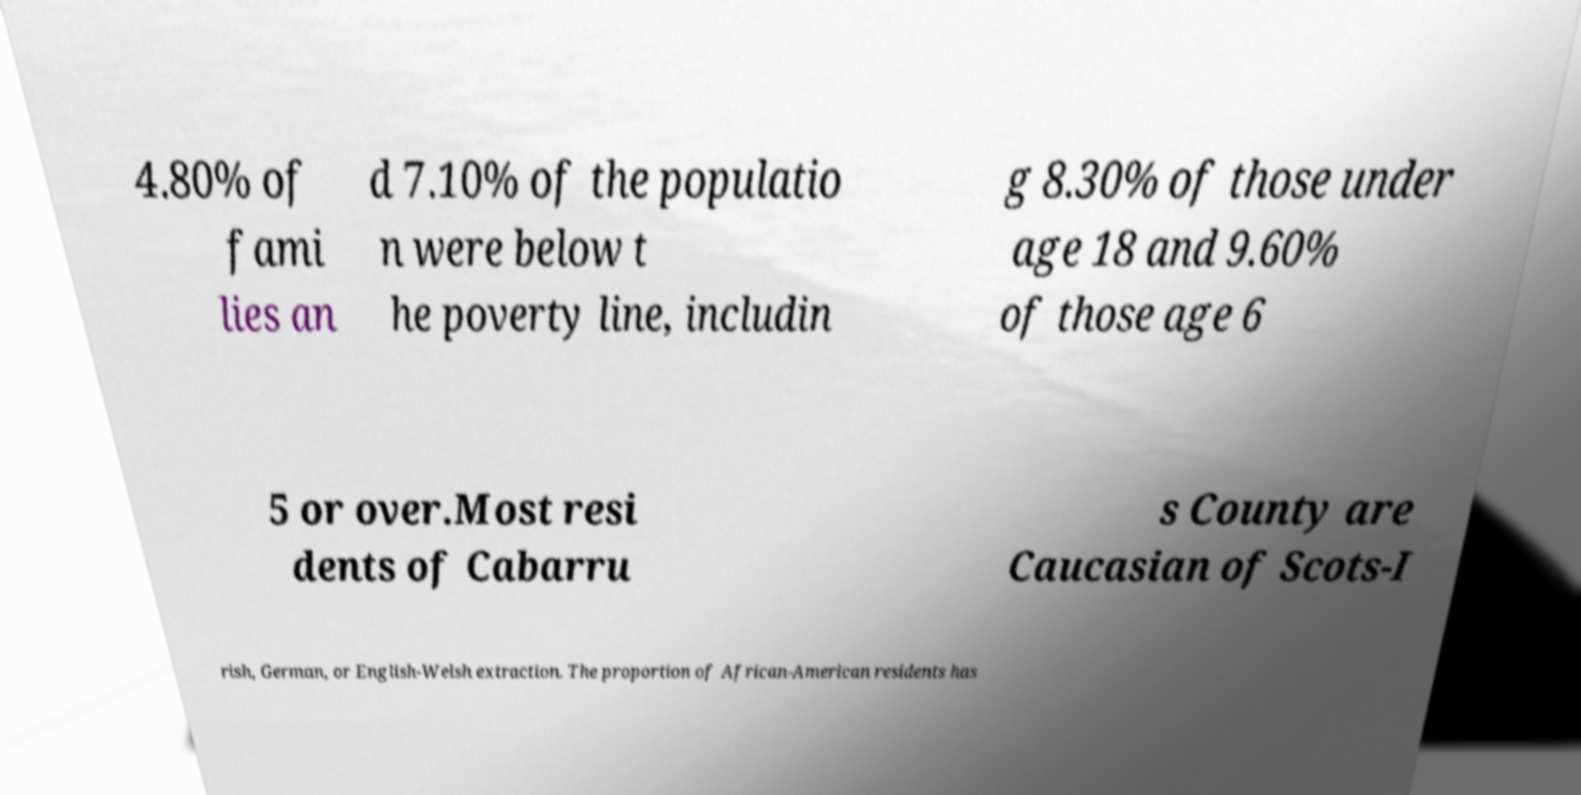There's text embedded in this image that I need extracted. Can you transcribe it verbatim? 4.80% of fami lies an d 7.10% of the populatio n were below t he poverty line, includin g 8.30% of those under age 18 and 9.60% of those age 6 5 or over.Most resi dents of Cabarru s County are Caucasian of Scots-I rish, German, or English-Welsh extraction. The proportion of African-American residents has 